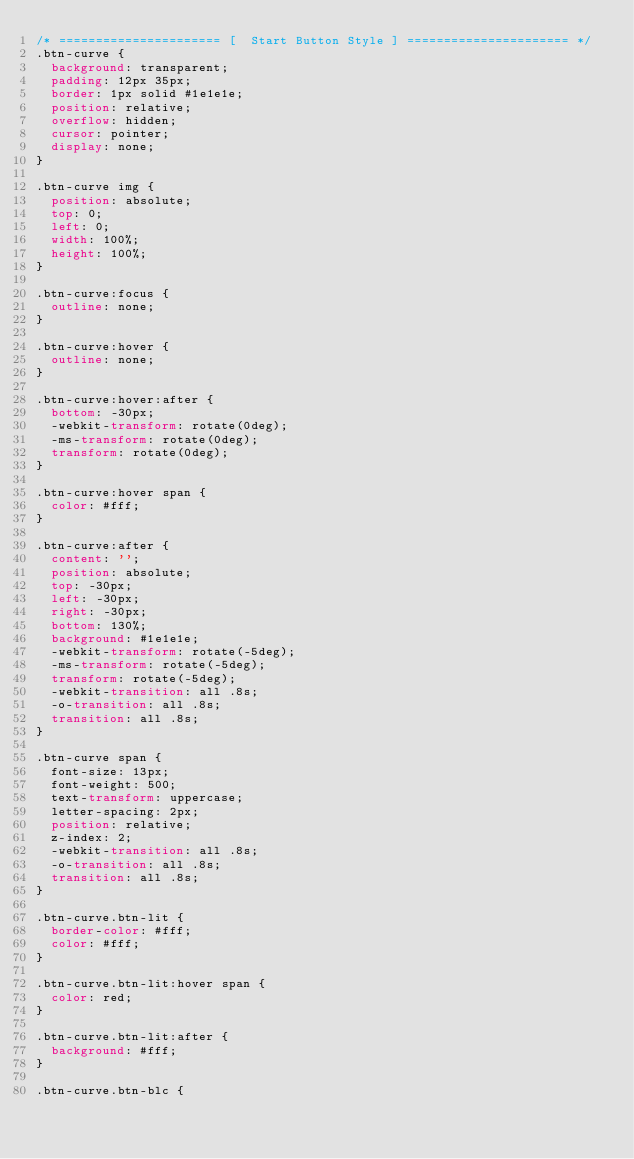Convert code to text. <code><loc_0><loc_0><loc_500><loc_500><_CSS_>/* ====================== [  Start Button Style ] ====================== */
.btn-curve {
  background: transparent;
  padding: 12px 35px;
  border: 1px solid #1e1e1e;
  position: relative;
  overflow: hidden;
  cursor: pointer;
  display: none;
}

.btn-curve img {
  position: absolute;
  top: 0;
  left: 0;
  width: 100%;
  height: 100%;
}

.btn-curve:focus {
  outline: none;
}

.btn-curve:hover {
  outline: none;
}

.btn-curve:hover:after {
  bottom: -30px;
  -webkit-transform: rotate(0deg);
  -ms-transform: rotate(0deg);
  transform: rotate(0deg);
}

.btn-curve:hover span {
  color: #fff;
}

.btn-curve:after {
  content: '';
  position: absolute;
  top: -30px;
  left: -30px;
  right: -30px;
  bottom: 130%;
  background: #1e1e1e;
  -webkit-transform: rotate(-5deg);
  -ms-transform: rotate(-5deg);
  transform: rotate(-5deg);
  -webkit-transition: all .8s;
  -o-transition: all .8s;
  transition: all .8s;
}

.btn-curve span {
  font-size: 13px;
  font-weight: 500;
  text-transform: uppercase;
  letter-spacing: 2px;
  position: relative;
  z-index: 2;
  -webkit-transition: all .8s;
  -o-transition: all .8s;
  transition: all .8s;
}

.btn-curve.btn-lit {
  border-color: #fff;
  color: #fff;
}

.btn-curve.btn-lit:hover span {
  color: red;
}

.btn-curve.btn-lit:after {
  background: #fff;
}

.btn-curve.btn-blc {</code> 